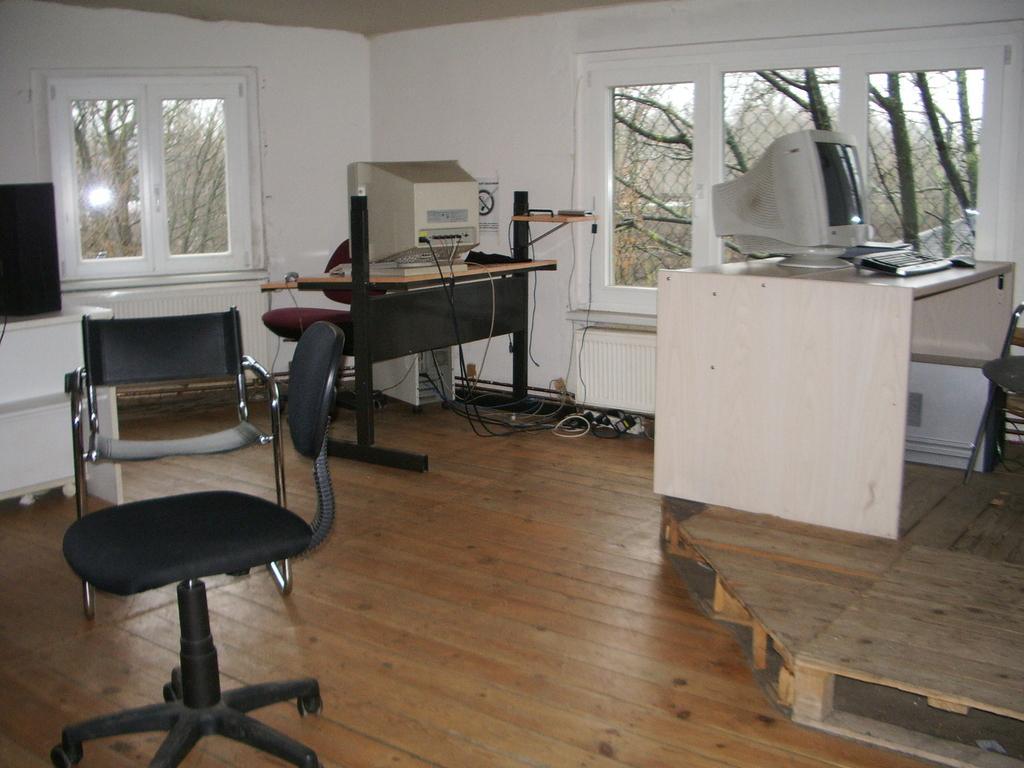Please provide a concise description of this image. This picture is clicked inside the room. On the left we can see the chairs and the tables on the top of which we can see the monitors, keyboard and some other items are placed. On the right there is a wooden object and there are some objects placed on the ground. In the background we can see the wall and the windows and through the windows we can see the outside view. 